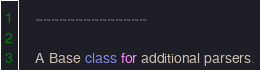Convert code to text. <code><loc_0><loc_0><loc_500><loc_500><_Python_>    ~~~~~~~~~~~~~~

    A Base class for additional parsers.
</code> 